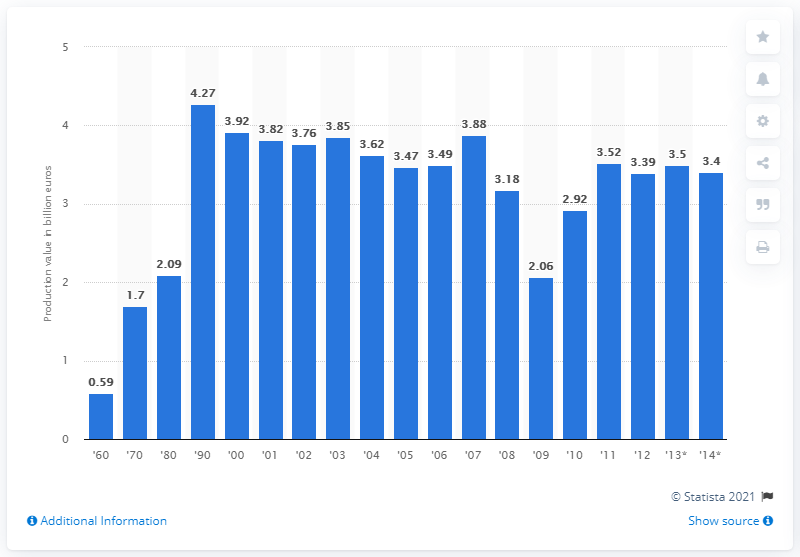Specify some key components in this picture. The value of Germany's textile machinery in 2011 was 3.5. 